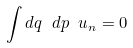Convert formula to latex. <formula><loc_0><loc_0><loc_500><loc_500>\int d q \ d p \ u _ { n } = 0</formula> 